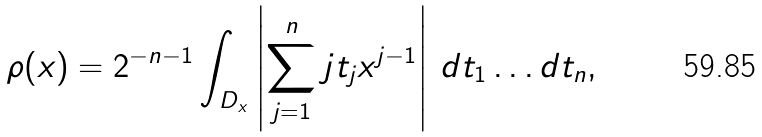Convert formula to latex. <formula><loc_0><loc_0><loc_500><loc_500>\rho ( x ) = 2 ^ { - n - 1 } \int _ { D _ { x } } \left | \sum _ { j = 1 } ^ { n } j t _ { j } x ^ { j - 1 } \right | \, d t _ { 1 } \dots d t _ { n } ,</formula> 